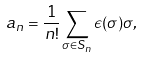<formula> <loc_0><loc_0><loc_500><loc_500>a _ { n } = \frac { 1 } { n ! } \sum _ { \sigma \in { S _ { n } } } \epsilon ( \sigma ) \sigma ,</formula> 